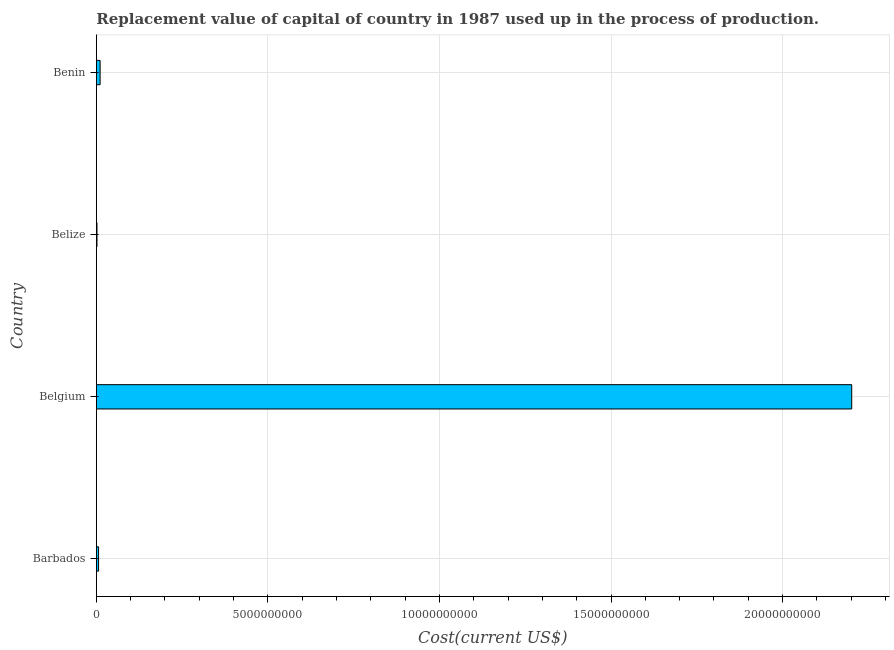Does the graph contain any zero values?
Provide a succinct answer. No. Does the graph contain grids?
Your response must be concise. Yes. What is the title of the graph?
Offer a terse response. Replacement value of capital of country in 1987 used up in the process of production. What is the label or title of the X-axis?
Keep it short and to the point. Cost(current US$). What is the label or title of the Y-axis?
Make the answer very short. Country. What is the consumption of fixed capital in Belize?
Provide a short and direct response. 1.84e+07. Across all countries, what is the maximum consumption of fixed capital?
Your response must be concise. 2.20e+1. Across all countries, what is the minimum consumption of fixed capital?
Your response must be concise. 1.84e+07. In which country was the consumption of fixed capital minimum?
Provide a succinct answer. Belize. What is the sum of the consumption of fixed capital?
Keep it short and to the point. 2.22e+1. What is the difference between the consumption of fixed capital in Barbados and Belize?
Give a very brief answer. 4.60e+07. What is the average consumption of fixed capital per country?
Provide a short and direct response. 5.55e+09. What is the median consumption of fixed capital?
Give a very brief answer. 8.69e+07. What is the ratio of the consumption of fixed capital in Belgium to that in Benin?
Offer a terse response. 201.05. Is the difference between the consumption of fixed capital in Belize and Benin greater than the difference between any two countries?
Offer a very short reply. No. What is the difference between the highest and the second highest consumption of fixed capital?
Your answer should be compact. 2.19e+1. Is the sum of the consumption of fixed capital in Barbados and Benin greater than the maximum consumption of fixed capital across all countries?
Give a very brief answer. No. What is the difference between the highest and the lowest consumption of fixed capital?
Your answer should be very brief. 2.20e+1. In how many countries, is the consumption of fixed capital greater than the average consumption of fixed capital taken over all countries?
Offer a very short reply. 1. How many bars are there?
Provide a succinct answer. 4. Are all the bars in the graph horizontal?
Make the answer very short. Yes. What is the Cost(current US$) in Barbados?
Provide a succinct answer. 6.44e+07. What is the Cost(current US$) of Belgium?
Give a very brief answer. 2.20e+1. What is the Cost(current US$) of Belize?
Make the answer very short. 1.84e+07. What is the Cost(current US$) in Benin?
Your answer should be compact. 1.10e+08. What is the difference between the Cost(current US$) in Barbados and Belgium?
Offer a very short reply. -2.20e+1. What is the difference between the Cost(current US$) in Barbados and Belize?
Give a very brief answer. 4.60e+07. What is the difference between the Cost(current US$) in Barbados and Benin?
Make the answer very short. -4.51e+07. What is the difference between the Cost(current US$) in Belgium and Belize?
Your answer should be compact. 2.20e+1. What is the difference between the Cost(current US$) in Belgium and Benin?
Give a very brief answer. 2.19e+1. What is the difference between the Cost(current US$) in Belize and Benin?
Provide a succinct answer. -9.12e+07. What is the ratio of the Cost(current US$) in Barbados to that in Belgium?
Your answer should be compact. 0. What is the ratio of the Cost(current US$) in Barbados to that in Belize?
Keep it short and to the point. 3.51. What is the ratio of the Cost(current US$) in Barbados to that in Benin?
Provide a succinct answer. 0.59. What is the ratio of the Cost(current US$) in Belgium to that in Belize?
Provide a succinct answer. 1199.57. What is the ratio of the Cost(current US$) in Belgium to that in Benin?
Your response must be concise. 201.05. What is the ratio of the Cost(current US$) in Belize to that in Benin?
Ensure brevity in your answer.  0.17. 